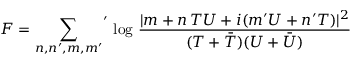Convert formula to latex. <formula><loc_0><loc_0><loc_500><loc_500>F = { \sum _ { n , n ^ { \prime } , m , m ^ { \prime } } } ^ { \prime } \, \log \, \frac { | m + n \, T U + i ( m ^ { \prime } U + n ^ { \prime } T ) | ^ { 2 } } { ( T + \bar { T } ) ( U + \bar { U } ) }</formula> 